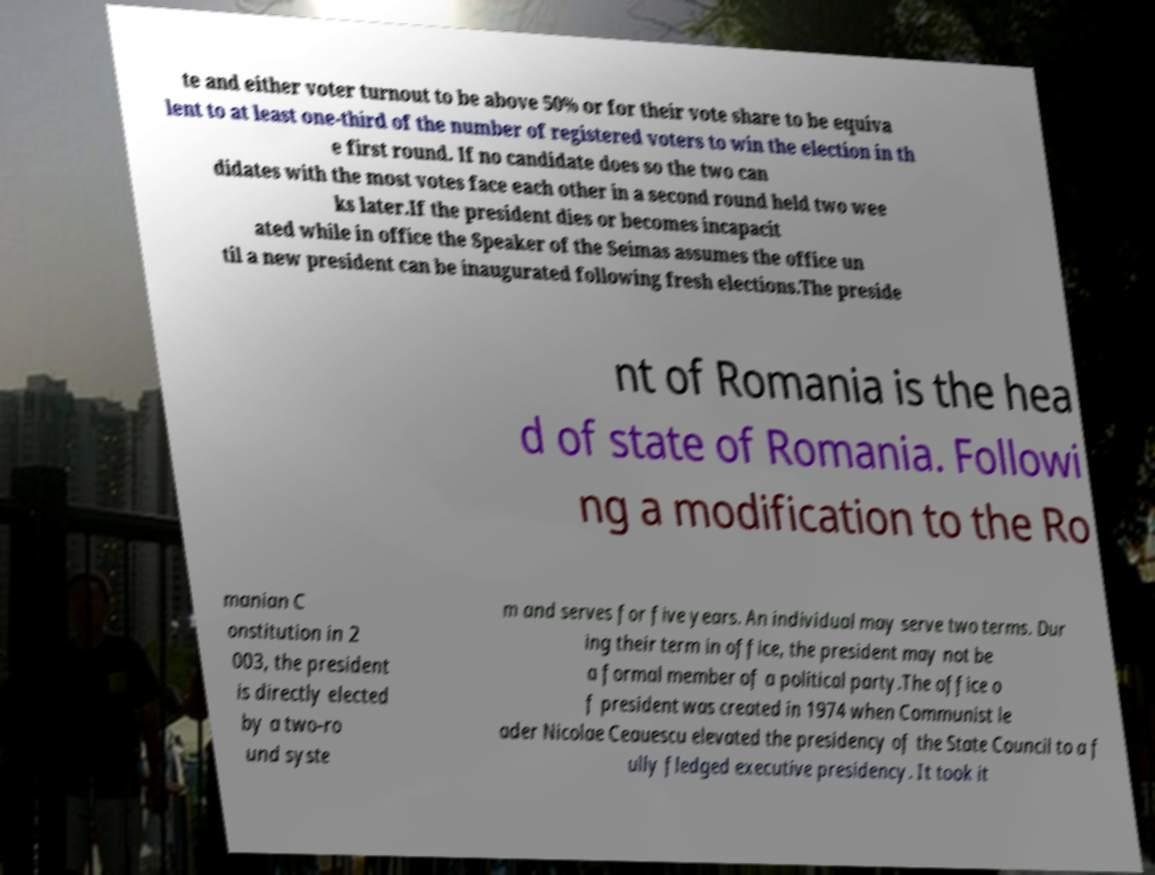Please identify and transcribe the text found in this image. te and either voter turnout to be above 50% or for their vote share to be equiva lent to at least one-third of the number of registered voters to win the election in th e first round. If no candidate does so the two can didates with the most votes face each other in a second round held two wee ks later.If the president dies or becomes incapacit ated while in office the Speaker of the Seimas assumes the office un til a new president can be inaugurated following fresh elections.The preside nt of Romania is the hea d of state of Romania. Followi ng a modification to the Ro manian C onstitution in 2 003, the president is directly elected by a two-ro und syste m and serves for five years. An individual may serve two terms. Dur ing their term in office, the president may not be a formal member of a political party.The office o f president was created in 1974 when Communist le ader Nicolae Ceauescu elevated the presidency of the State Council to a f ully fledged executive presidency. It took it 